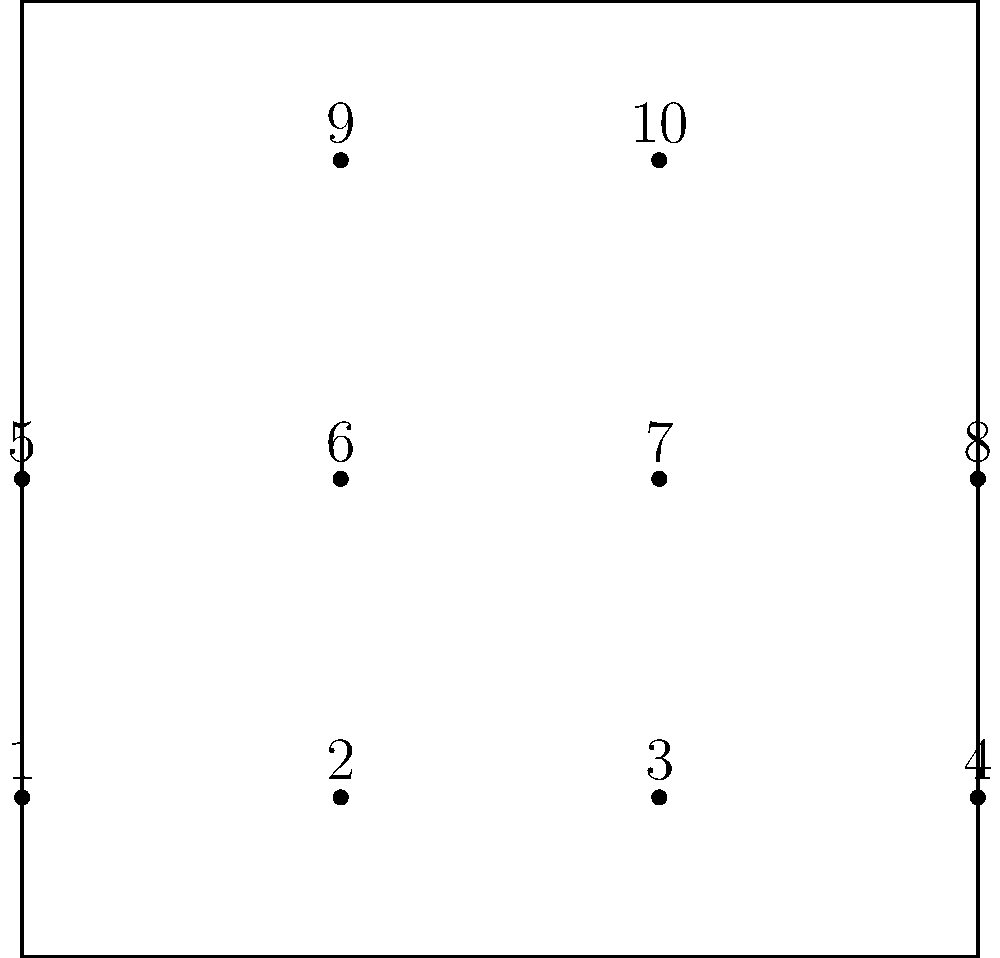In a 4-4-2 formation represented by dots, players rotate positions clockwise. If player 1 moves to position 2, player 2 to position 3, and so on, how many rotations are needed for all players to return to their original positions? Let's approach this step-by-step:

1) First, we need to understand the cycle of rotation. Let's follow player 1:
   1 → 2 → 3 → 4 → 8 → 7 → 6 → 5 → 1

2) We see that player 1 returns to its original position after 8 moves.

3) Now, let's check player 9:
   9 → 10 → 9

4) Player 9 returns to its original position after 2 moves.

5) In group theory, this is a permutation with two cycles: one of length 8 and one of length 2.

6) To find when all players return to their original positions simultaneously, we need to find the least common multiple (LCM) of these cycle lengths.

7) $LCM(8, 2) = 8$

Therefore, after 8 rotations, all players will be back in their original positions.
Answer: 8 rotations 